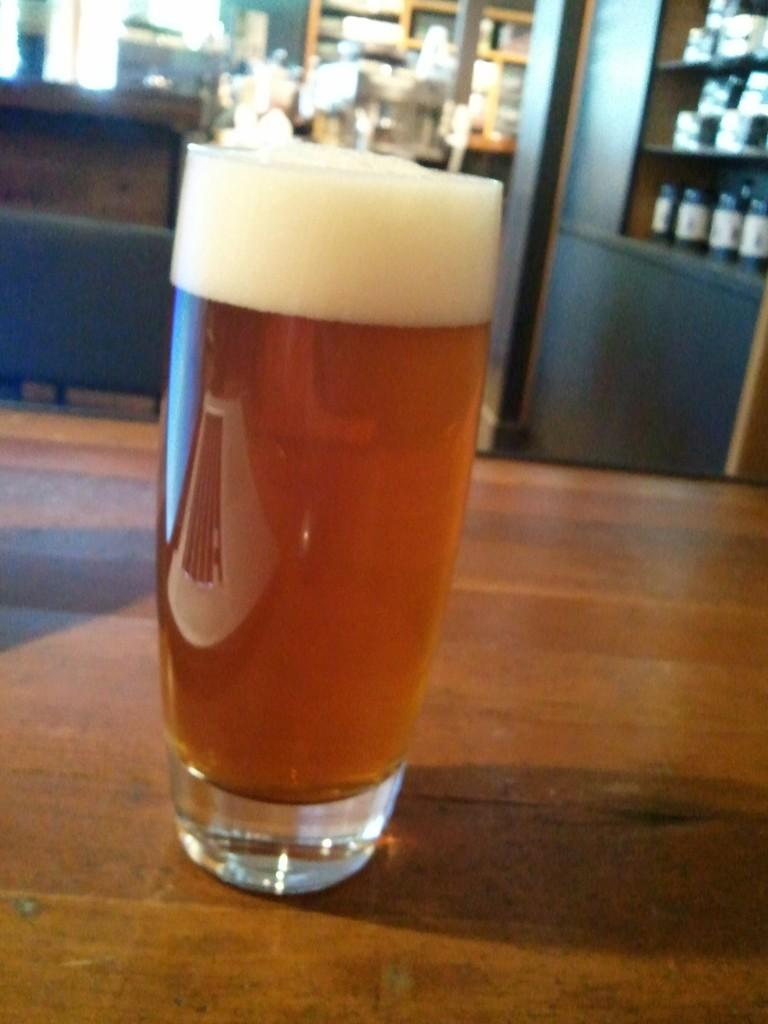What is located in the center of the image? There is a table in the center of the image. What can be seen on the table? There is a glass on the table. What is visible in the background of the image? There is a wall, lights, tables, racks, jars, and a few other objects in the background of the image. What type of lumber is being used to construct the statement in the image? There is no statement or lumber present in the image. How many times does the fold occur in the image? There is no fold present in the image. 